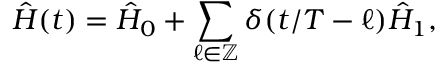<formula> <loc_0><loc_0><loc_500><loc_500>\hat { H } ( t ) = \hat { H } _ { 0 } + \sum _ { \ell \in \mathbb { Z } } \delta ( t / T - \ell ) \hat { H } _ { 1 } ,</formula> 